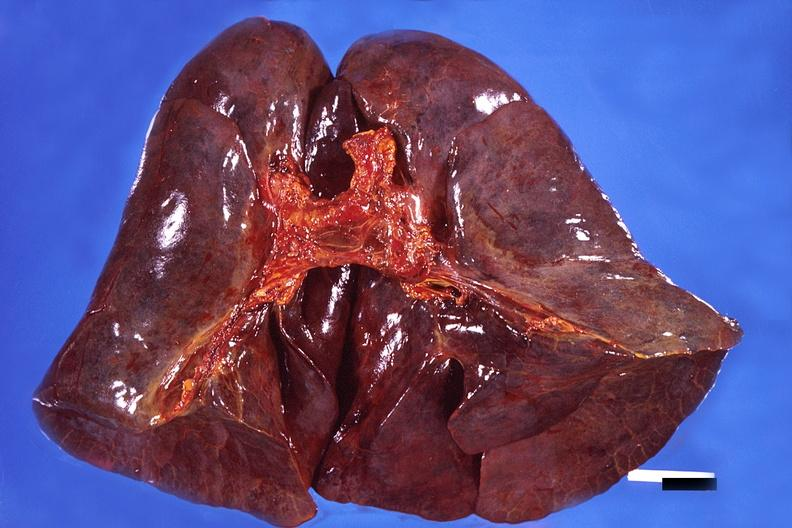s granuloma present?
Answer the question using a single word or phrase. No 